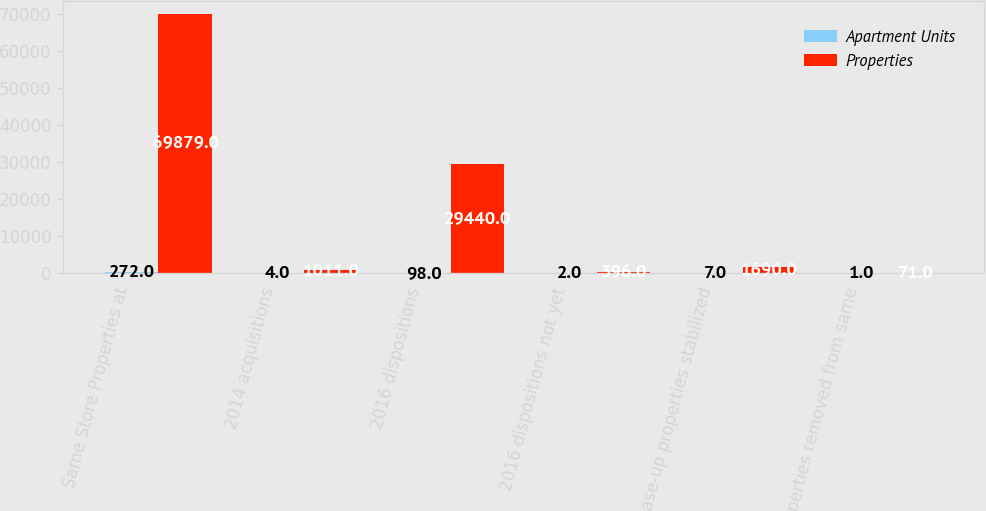<chart> <loc_0><loc_0><loc_500><loc_500><stacked_bar_chart><ecel><fcel>Same Store Properties at<fcel>2014 acquisitions<fcel>2016 dispositions<fcel>2016 dispositions not yet<fcel>Lease-up properties stabilized<fcel>Properties removed from same<nl><fcel>Apartment Units<fcel>272<fcel>4<fcel>98<fcel>2<fcel>7<fcel>1<nl><fcel>Properties<fcel>69879<fcel>1011<fcel>29440<fcel>396<fcel>1690<fcel>71<nl></chart> 